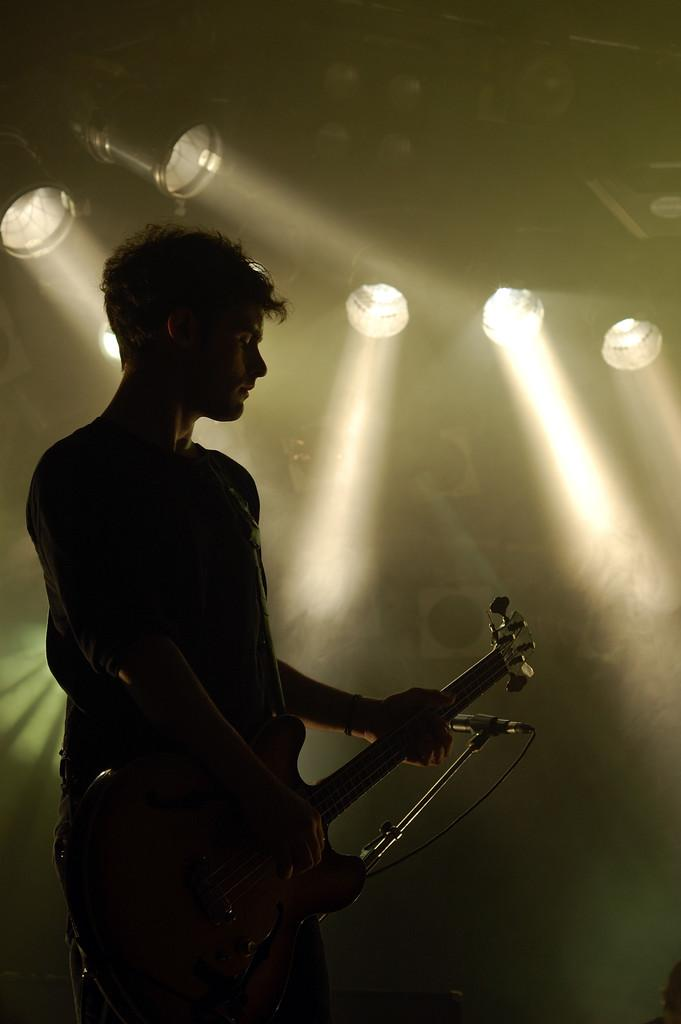Who is present in the image? There is a man in the image. Where is the man located? The man is standing on a stage. What is the man holding in the image? The man is holding a guitar. What equipment is in front of the man? There is a microphone with a stand in front of the man. What can be seen in the background of the image? There are lights and smoke visible in the image. How many bikes are visible in the image? There are no bikes present in the image. What type of coal is being used to fuel the stage lights in the image? There is no coal present in the image, and the type of fuel used for the lights is not mentioned. 